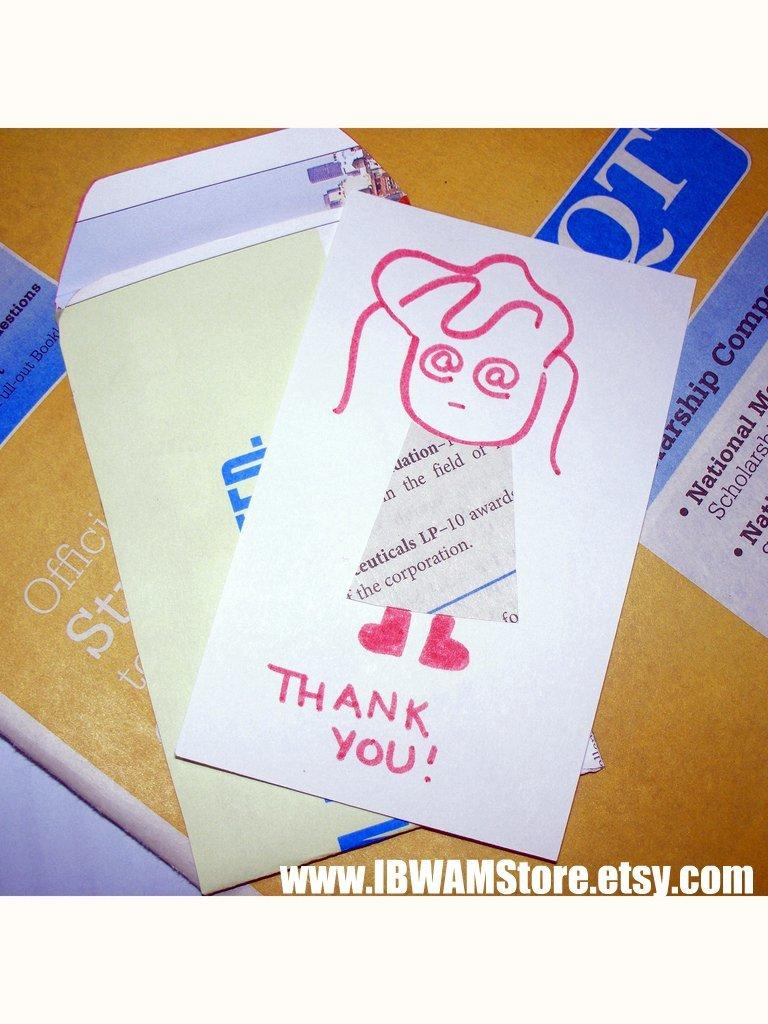<image>
Render a clear and concise summary of the photo. A Thank You card With a drawing of a girl on the front and Thank you written in red across the bottom. 